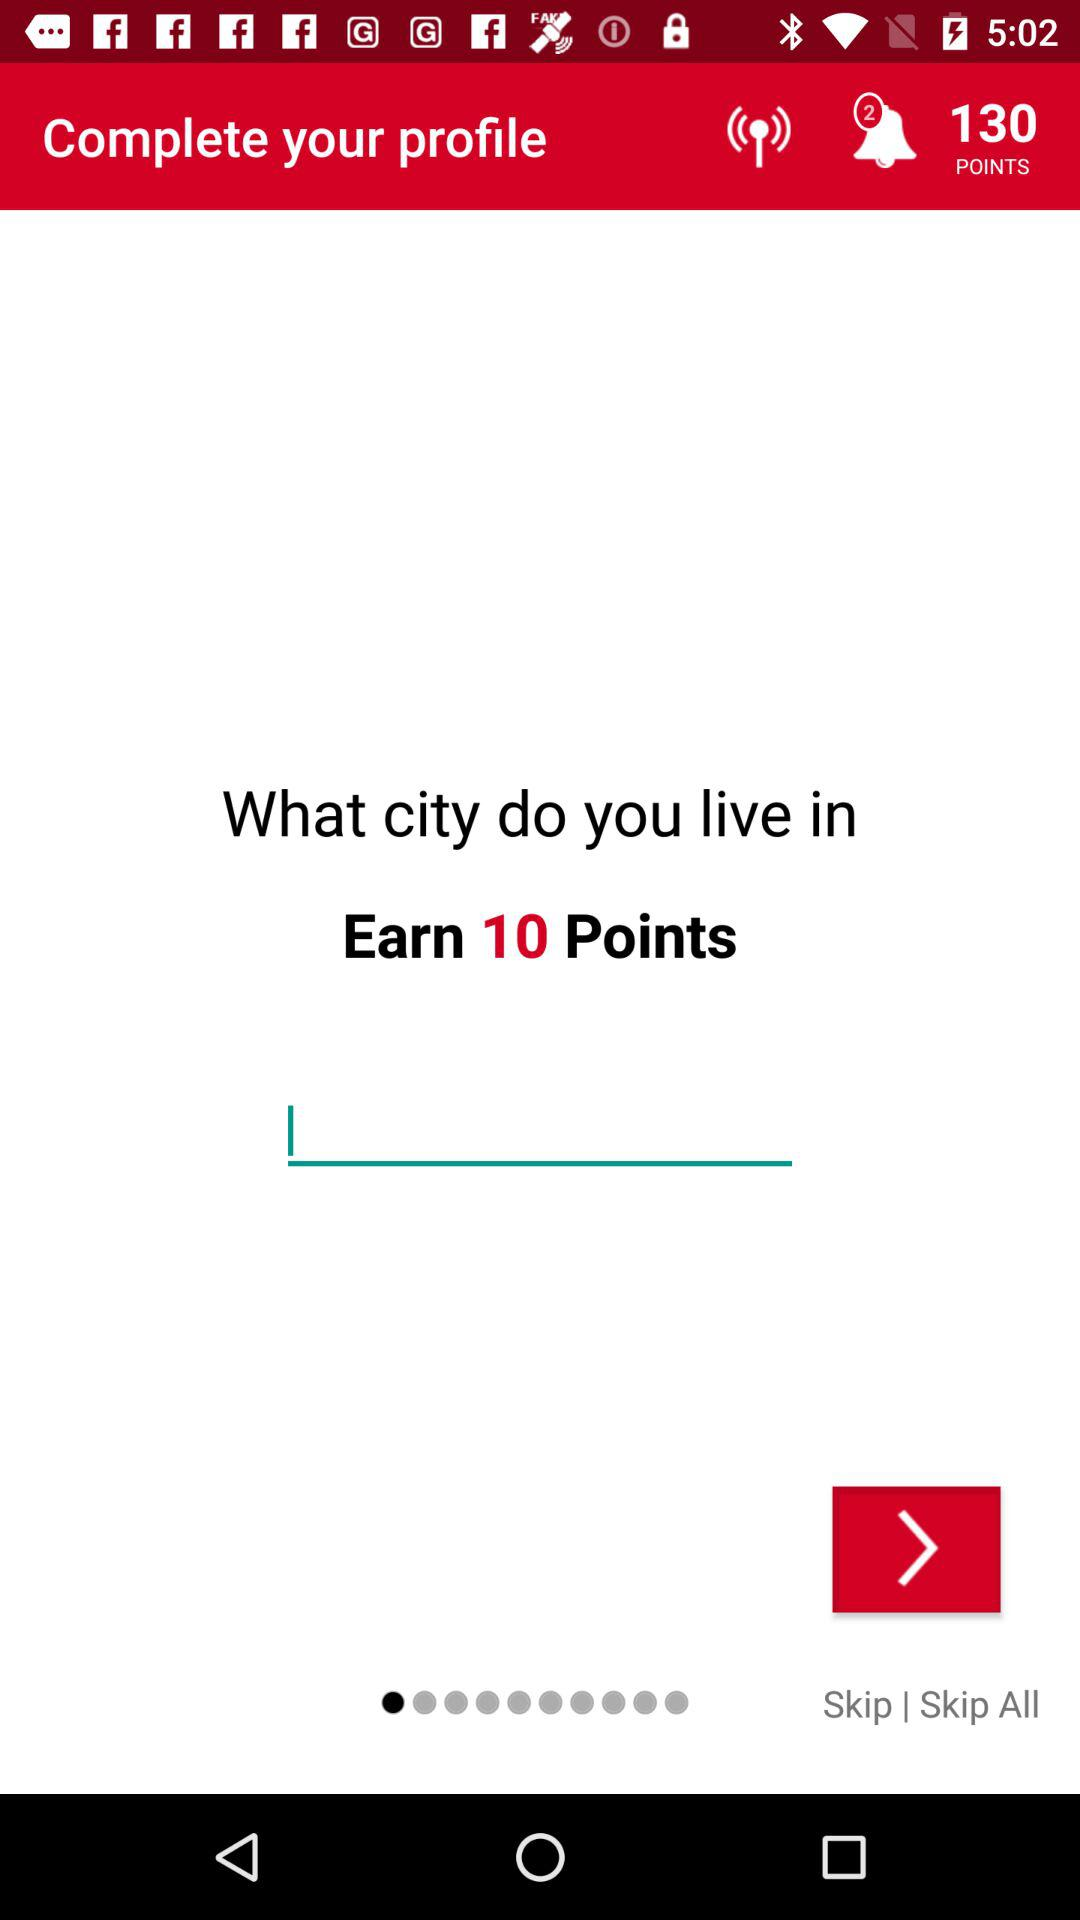How many points can we earn? You can earn 10 points. 